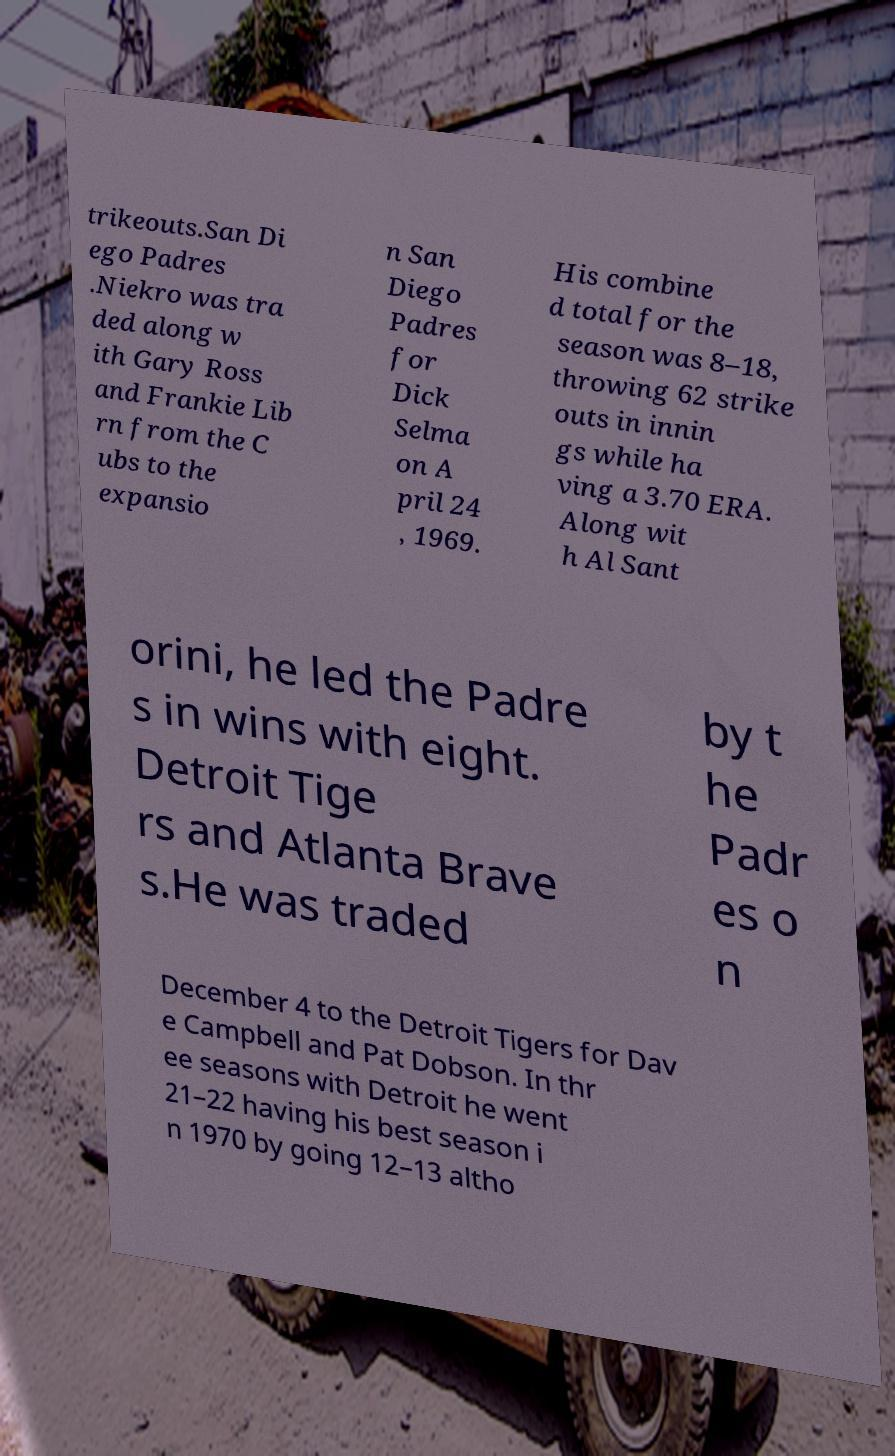Please read and relay the text visible in this image. What does it say? trikeouts.San Di ego Padres .Niekro was tra ded along w ith Gary Ross and Frankie Lib rn from the C ubs to the expansio n San Diego Padres for Dick Selma on A pril 24 , 1969. His combine d total for the season was 8–18, throwing 62 strike outs in innin gs while ha ving a 3.70 ERA. Along wit h Al Sant orini, he led the Padre s in wins with eight. Detroit Tige rs and Atlanta Brave s.He was traded by t he Padr es o n December 4 to the Detroit Tigers for Dav e Campbell and Pat Dobson. In thr ee seasons with Detroit he went 21–22 having his best season i n 1970 by going 12–13 altho 